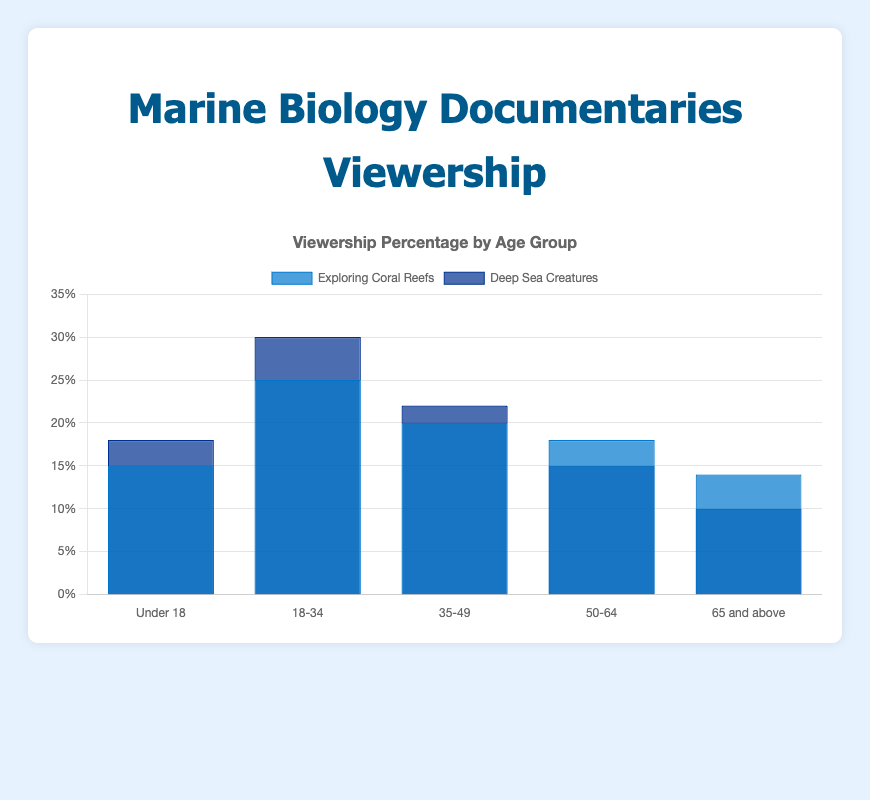What age group has the highest viewership for "Deep Sea Creatures"? By looking at the height of the bars for "Deep Sea Creatures" in each age group, the highest bar corresponds to the 18-34 age group with a viewership percentage of 30%.
Answer: 18-34 Which documentary has a higher viewership percentage for the age group 50-64? Compare the bars for both documentaries within the 50-64 age group. The bar for "Exploring Coral Reefs" is higher at 18% compared to 15% for "Deep Sea Creatures".
Answer: Exploring Coral Reefs What is the total viewership percentage for "Exploring Coral Reefs" across all age groups? Sum the viewership percentages for "Exploring Coral Reefs" across all age groups: 15 + 25 + 20 + 18 + 14 = 92%.
Answer: 92% In which age group is the viewership percentage for "Exploring Coral Reefs" lower than "Deep Sea Creatures"? Compare the bars for each age group. "Exploring Coral Reefs" has a lower viewership percentage than "Deep Sea Creatures" in the age groups Under 18 (15% vs 18%), 18-34 (25% vs 30%), 35-49 (20% vs 22%), and 65 and above (14% vs 10%).
Answer: Under 18, 18-34, 35-49, 65 and above By how much does the viewership percentage for "Deep Sea Creatures" in the 18-34 age group exceed that of the 65 and above age group? Subtract the viewership percentage of the 65 and above age group (10%) from that of the 18-34 age group (30%): 30% - 10% = 20%.
Answer: 20% Which documentary has a consistent viewership percentage across all age groups? Compare the viewership percentages for each documentary across all age groups. "Exploring Coral Reefs" has varying percentages: 15, 25, 20, 18, and 14. "Deep Sea Creatures" also has varying percentages: 18, 30, 22, 15, and 10. Neither of the documentaries has consistent viewership across all age groups.
Answer: Neither What is the difference in viewership percentage between the 18-34 and 35-49 age groups for "Deep Sea Creatures"? Subtract the viewership percentage of the 35-49 age group (22%) from that of the 18-34 age group (30%): 30% - 22% = 8%.
Answer: 8% Which age group has the lowest viewership percentage for "Exploring Coral Reefs"? By looking at the bars for "Exploring Coral Reefs", the lowest bar corresponds to the 65 and above age group with a viewership percentage of 14%.
Answer: 65 and above What is the average viewership percentage for "Deep Sea Creatures" across all age groups? Sum the viewership percentages for "Deep Sea Creatures" and divide by the number of age groups: (18 + 30 + 22 + 15 + 10) / 5 = 95 / 5 = 19%.
Answer: 19% Which documentary has a higher overall viewership percentage? Calculate the total viewership percentage for each documentary: "Exploring Coral Reefs" - 92%; "Deep Sea Creatures" - 95%. "Deep Sea Creatures" has a higher overall viewership percentage.
Answer: Deep Sea Creatures 